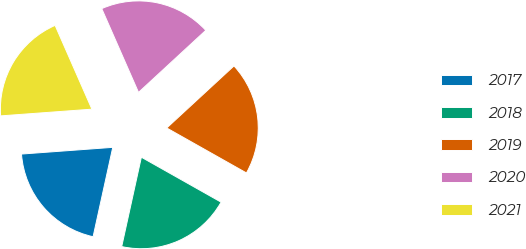Convert chart. <chart><loc_0><loc_0><loc_500><loc_500><pie_chart><fcel>2017<fcel>2018<fcel>2019<fcel>2020<fcel>2021<nl><fcel>20.38%<fcel>20.27%<fcel>20.03%<fcel>19.72%<fcel>19.58%<nl></chart> 